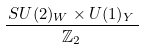<formula> <loc_0><loc_0><loc_500><loc_500>\frac { \, S U ( 2 ) _ { W } \times U ( 1 ) _ { Y } \, } { \mathbb { Z } _ { 2 } }</formula> 